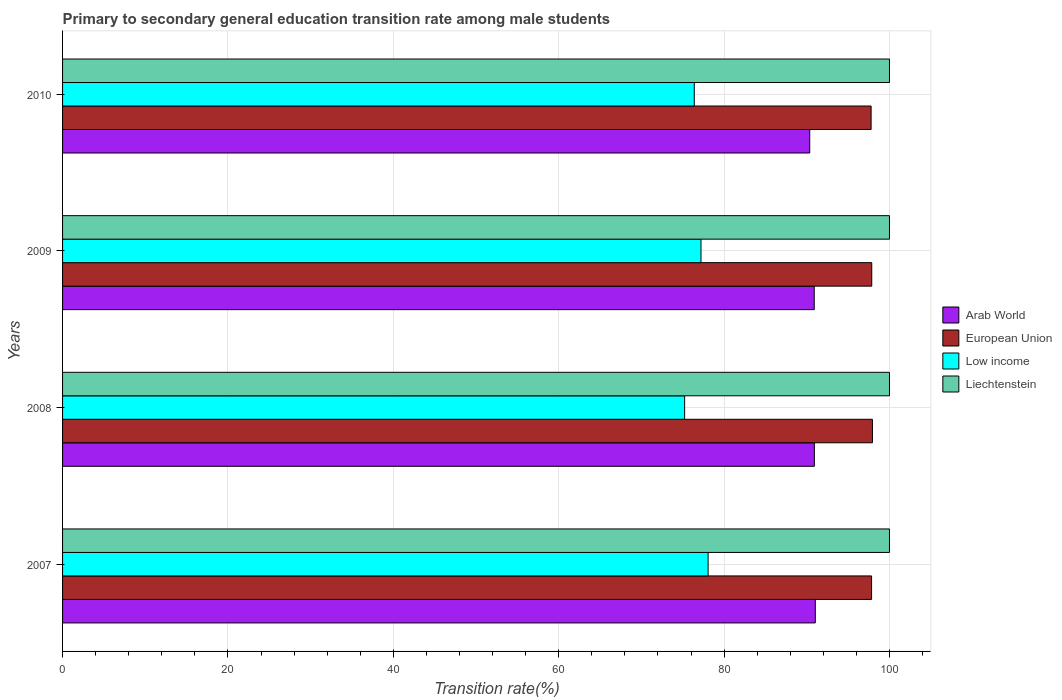How many different coloured bars are there?
Ensure brevity in your answer.  4. How many groups of bars are there?
Ensure brevity in your answer.  4. Are the number of bars on each tick of the Y-axis equal?
Offer a terse response. Yes. How many bars are there on the 2nd tick from the bottom?
Provide a succinct answer. 4. What is the label of the 4th group of bars from the top?
Your answer should be compact. 2007. In how many cases, is the number of bars for a given year not equal to the number of legend labels?
Provide a succinct answer. 0. What is the transition rate in Arab World in 2009?
Provide a succinct answer. 90.9. Across all years, what is the maximum transition rate in Arab World?
Provide a succinct answer. 91.03. Across all years, what is the minimum transition rate in Arab World?
Provide a succinct answer. 90.36. In which year was the transition rate in European Union minimum?
Your answer should be very brief. 2010. What is the total transition rate in Low income in the graph?
Your answer should be compact. 306.89. What is the difference between the transition rate in Arab World in 2007 and that in 2008?
Offer a very short reply. 0.12. What is the difference between the transition rate in Low income in 2008 and the transition rate in Liechtenstein in 2007?
Make the answer very short. -24.77. What is the average transition rate in Liechtenstein per year?
Your answer should be very brief. 100. In the year 2008, what is the difference between the transition rate in Liechtenstein and transition rate in Arab World?
Keep it short and to the point. 9.08. What is the ratio of the transition rate in European Union in 2007 to that in 2009?
Make the answer very short. 1. Is the transition rate in Low income in 2008 less than that in 2010?
Your response must be concise. Yes. What is the difference between the highest and the second highest transition rate in Low income?
Provide a short and direct response. 0.86. What is the difference between the highest and the lowest transition rate in Liechtenstein?
Give a very brief answer. 0. Is it the case that in every year, the sum of the transition rate in Arab World and transition rate in European Union is greater than the transition rate in Liechtenstein?
Keep it short and to the point. Yes. Does the graph contain any zero values?
Your response must be concise. No. Does the graph contain grids?
Provide a short and direct response. Yes. Where does the legend appear in the graph?
Your response must be concise. Center right. How are the legend labels stacked?
Provide a succinct answer. Vertical. What is the title of the graph?
Provide a short and direct response. Primary to secondary general education transition rate among male students. What is the label or title of the X-axis?
Make the answer very short. Transition rate(%). What is the Transition rate(%) in Arab World in 2007?
Your answer should be compact. 91.03. What is the Transition rate(%) of European Union in 2007?
Offer a very short reply. 97.84. What is the Transition rate(%) of Low income in 2007?
Offer a very short reply. 78.07. What is the Transition rate(%) in Arab World in 2008?
Make the answer very short. 90.92. What is the Transition rate(%) in European Union in 2008?
Provide a short and direct response. 97.94. What is the Transition rate(%) in Low income in 2008?
Provide a short and direct response. 75.23. What is the Transition rate(%) in Arab World in 2009?
Give a very brief answer. 90.9. What is the Transition rate(%) in European Union in 2009?
Provide a succinct answer. 97.86. What is the Transition rate(%) of Low income in 2009?
Keep it short and to the point. 77.21. What is the Transition rate(%) in Liechtenstein in 2009?
Give a very brief answer. 100. What is the Transition rate(%) in Arab World in 2010?
Provide a short and direct response. 90.36. What is the Transition rate(%) in European Union in 2010?
Provide a succinct answer. 97.78. What is the Transition rate(%) of Low income in 2010?
Your answer should be compact. 76.39. What is the Transition rate(%) in Liechtenstein in 2010?
Give a very brief answer. 100. Across all years, what is the maximum Transition rate(%) in Arab World?
Provide a succinct answer. 91.03. Across all years, what is the maximum Transition rate(%) in European Union?
Keep it short and to the point. 97.94. Across all years, what is the maximum Transition rate(%) in Low income?
Your answer should be very brief. 78.07. Across all years, what is the maximum Transition rate(%) in Liechtenstein?
Your response must be concise. 100. Across all years, what is the minimum Transition rate(%) in Arab World?
Provide a short and direct response. 90.36. Across all years, what is the minimum Transition rate(%) of European Union?
Your answer should be compact. 97.78. Across all years, what is the minimum Transition rate(%) in Low income?
Offer a terse response. 75.23. What is the total Transition rate(%) in Arab World in the graph?
Provide a succinct answer. 363.2. What is the total Transition rate(%) in European Union in the graph?
Your response must be concise. 391.41. What is the total Transition rate(%) of Low income in the graph?
Your answer should be very brief. 306.89. What is the total Transition rate(%) in Liechtenstein in the graph?
Your response must be concise. 400. What is the difference between the Transition rate(%) of Arab World in 2007 and that in 2008?
Make the answer very short. 0.12. What is the difference between the Transition rate(%) in European Union in 2007 and that in 2008?
Give a very brief answer. -0.1. What is the difference between the Transition rate(%) in Low income in 2007 and that in 2008?
Provide a short and direct response. 2.84. What is the difference between the Transition rate(%) in Liechtenstein in 2007 and that in 2008?
Ensure brevity in your answer.  0. What is the difference between the Transition rate(%) of Arab World in 2007 and that in 2009?
Offer a very short reply. 0.13. What is the difference between the Transition rate(%) in European Union in 2007 and that in 2009?
Your response must be concise. -0.02. What is the difference between the Transition rate(%) of Low income in 2007 and that in 2009?
Keep it short and to the point. 0.86. What is the difference between the Transition rate(%) in Arab World in 2007 and that in 2010?
Ensure brevity in your answer.  0.67. What is the difference between the Transition rate(%) in European Union in 2007 and that in 2010?
Your answer should be compact. 0.06. What is the difference between the Transition rate(%) of Low income in 2007 and that in 2010?
Offer a very short reply. 1.67. What is the difference between the Transition rate(%) in Liechtenstein in 2007 and that in 2010?
Offer a very short reply. 0. What is the difference between the Transition rate(%) of Arab World in 2008 and that in 2009?
Offer a terse response. 0.01. What is the difference between the Transition rate(%) of European Union in 2008 and that in 2009?
Offer a terse response. 0.08. What is the difference between the Transition rate(%) in Low income in 2008 and that in 2009?
Provide a short and direct response. -1.98. What is the difference between the Transition rate(%) in Liechtenstein in 2008 and that in 2009?
Your answer should be very brief. 0. What is the difference between the Transition rate(%) in Arab World in 2008 and that in 2010?
Make the answer very short. 0.56. What is the difference between the Transition rate(%) of European Union in 2008 and that in 2010?
Your answer should be very brief. 0.16. What is the difference between the Transition rate(%) in Low income in 2008 and that in 2010?
Provide a short and direct response. -1.17. What is the difference between the Transition rate(%) of Liechtenstein in 2008 and that in 2010?
Offer a very short reply. 0. What is the difference between the Transition rate(%) in Arab World in 2009 and that in 2010?
Provide a succinct answer. 0.54. What is the difference between the Transition rate(%) in European Union in 2009 and that in 2010?
Offer a very short reply. 0.08. What is the difference between the Transition rate(%) in Low income in 2009 and that in 2010?
Offer a very short reply. 0.81. What is the difference between the Transition rate(%) of Arab World in 2007 and the Transition rate(%) of European Union in 2008?
Ensure brevity in your answer.  -6.91. What is the difference between the Transition rate(%) of Arab World in 2007 and the Transition rate(%) of Low income in 2008?
Offer a terse response. 15.8. What is the difference between the Transition rate(%) in Arab World in 2007 and the Transition rate(%) in Liechtenstein in 2008?
Your answer should be compact. -8.97. What is the difference between the Transition rate(%) of European Union in 2007 and the Transition rate(%) of Low income in 2008?
Provide a succinct answer. 22.61. What is the difference between the Transition rate(%) of European Union in 2007 and the Transition rate(%) of Liechtenstein in 2008?
Provide a short and direct response. -2.16. What is the difference between the Transition rate(%) of Low income in 2007 and the Transition rate(%) of Liechtenstein in 2008?
Ensure brevity in your answer.  -21.93. What is the difference between the Transition rate(%) in Arab World in 2007 and the Transition rate(%) in European Union in 2009?
Your answer should be very brief. -6.83. What is the difference between the Transition rate(%) of Arab World in 2007 and the Transition rate(%) of Low income in 2009?
Make the answer very short. 13.83. What is the difference between the Transition rate(%) in Arab World in 2007 and the Transition rate(%) in Liechtenstein in 2009?
Provide a short and direct response. -8.97. What is the difference between the Transition rate(%) of European Union in 2007 and the Transition rate(%) of Low income in 2009?
Ensure brevity in your answer.  20.63. What is the difference between the Transition rate(%) in European Union in 2007 and the Transition rate(%) in Liechtenstein in 2009?
Give a very brief answer. -2.16. What is the difference between the Transition rate(%) in Low income in 2007 and the Transition rate(%) in Liechtenstein in 2009?
Your answer should be compact. -21.93. What is the difference between the Transition rate(%) of Arab World in 2007 and the Transition rate(%) of European Union in 2010?
Keep it short and to the point. -6.75. What is the difference between the Transition rate(%) of Arab World in 2007 and the Transition rate(%) of Low income in 2010?
Provide a short and direct response. 14.64. What is the difference between the Transition rate(%) of Arab World in 2007 and the Transition rate(%) of Liechtenstein in 2010?
Offer a terse response. -8.97. What is the difference between the Transition rate(%) in European Union in 2007 and the Transition rate(%) in Low income in 2010?
Offer a terse response. 21.44. What is the difference between the Transition rate(%) of European Union in 2007 and the Transition rate(%) of Liechtenstein in 2010?
Provide a succinct answer. -2.16. What is the difference between the Transition rate(%) in Low income in 2007 and the Transition rate(%) in Liechtenstein in 2010?
Provide a short and direct response. -21.93. What is the difference between the Transition rate(%) of Arab World in 2008 and the Transition rate(%) of European Union in 2009?
Ensure brevity in your answer.  -6.94. What is the difference between the Transition rate(%) in Arab World in 2008 and the Transition rate(%) in Low income in 2009?
Provide a short and direct response. 13.71. What is the difference between the Transition rate(%) in Arab World in 2008 and the Transition rate(%) in Liechtenstein in 2009?
Ensure brevity in your answer.  -9.08. What is the difference between the Transition rate(%) in European Union in 2008 and the Transition rate(%) in Low income in 2009?
Your answer should be compact. 20.73. What is the difference between the Transition rate(%) in European Union in 2008 and the Transition rate(%) in Liechtenstein in 2009?
Offer a terse response. -2.06. What is the difference between the Transition rate(%) of Low income in 2008 and the Transition rate(%) of Liechtenstein in 2009?
Provide a short and direct response. -24.77. What is the difference between the Transition rate(%) of Arab World in 2008 and the Transition rate(%) of European Union in 2010?
Give a very brief answer. -6.86. What is the difference between the Transition rate(%) of Arab World in 2008 and the Transition rate(%) of Low income in 2010?
Ensure brevity in your answer.  14.52. What is the difference between the Transition rate(%) of Arab World in 2008 and the Transition rate(%) of Liechtenstein in 2010?
Your response must be concise. -9.08. What is the difference between the Transition rate(%) of European Union in 2008 and the Transition rate(%) of Low income in 2010?
Provide a succinct answer. 21.54. What is the difference between the Transition rate(%) in European Union in 2008 and the Transition rate(%) in Liechtenstein in 2010?
Your answer should be very brief. -2.06. What is the difference between the Transition rate(%) in Low income in 2008 and the Transition rate(%) in Liechtenstein in 2010?
Provide a succinct answer. -24.77. What is the difference between the Transition rate(%) of Arab World in 2009 and the Transition rate(%) of European Union in 2010?
Offer a terse response. -6.88. What is the difference between the Transition rate(%) in Arab World in 2009 and the Transition rate(%) in Low income in 2010?
Ensure brevity in your answer.  14.51. What is the difference between the Transition rate(%) of Arab World in 2009 and the Transition rate(%) of Liechtenstein in 2010?
Make the answer very short. -9.1. What is the difference between the Transition rate(%) of European Union in 2009 and the Transition rate(%) of Low income in 2010?
Make the answer very short. 21.46. What is the difference between the Transition rate(%) in European Union in 2009 and the Transition rate(%) in Liechtenstein in 2010?
Give a very brief answer. -2.14. What is the difference between the Transition rate(%) of Low income in 2009 and the Transition rate(%) of Liechtenstein in 2010?
Make the answer very short. -22.79. What is the average Transition rate(%) in Arab World per year?
Keep it short and to the point. 90.8. What is the average Transition rate(%) of European Union per year?
Ensure brevity in your answer.  97.85. What is the average Transition rate(%) of Low income per year?
Your answer should be compact. 76.72. What is the average Transition rate(%) in Liechtenstein per year?
Give a very brief answer. 100. In the year 2007, what is the difference between the Transition rate(%) of Arab World and Transition rate(%) of European Union?
Keep it short and to the point. -6.8. In the year 2007, what is the difference between the Transition rate(%) in Arab World and Transition rate(%) in Low income?
Keep it short and to the point. 12.96. In the year 2007, what is the difference between the Transition rate(%) of Arab World and Transition rate(%) of Liechtenstein?
Provide a short and direct response. -8.97. In the year 2007, what is the difference between the Transition rate(%) in European Union and Transition rate(%) in Low income?
Make the answer very short. 19.77. In the year 2007, what is the difference between the Transition rate(%) of European Union and Transition rate(%) of Liechtenstein?
Provide a succinct answer. -2.16. In the year 2007, what is the difference between the Transition rate(%) in Low income and Transition rate(%) in Liechtenstein?
Provide a short and direct response. -21.93. In the year 2008, what is the difference between the Transition rate(%) in Arab World and Transition rate(%) in European Union?
Provide a short and direct response. -7.02. In the year 2008, what is the difference between the Transition rate(%) of Arab World and Transition rate(%) of Low income?
Make the answer very short. 15.69. In the year 2008, what is the difference between the Transition rate(%) of Arab World and Transition rate(%) of Liechtenstein?
Provide a succinct answer. -9.08. In the year 2008, what is the difference between the Transition rate(%) in European Union and Transition rate(%) in Low income?
Offer a very short reply. 22.71. In the year 2008, what is the difference between the Transition rate(%) in European Union and Transition rate(%) in Liechtenstein?
Ensure brevity in your answer.  -2.06. In the year 2008, what is the difference between the Transition rate(%) of Low income and Transition rate(%) of Liechtenstein?
Your answer should be compact. -24.77. In the year 2009, what is the difference between the Transition rate(%) of Arab World and Transition rate(%) of European Union?
Make the answer very short. -6.96. In the year 2009, what is the difference between the Transition rate(%) of Arab World and Transition rate(%) of Low income?
Your answer should be very brief. 13.7. In the year 2009, what is the difference between the Transition rate(%) of Arab World and Transition rate(%) of Liechtenstein?
Offer a very short reply. -9.1. In the year 2009, what is the difference between the Transition rate(%) of European Union and Transition rate(%) of Low income?
Offer a very short reply. 20.65. In the year 2009, what is the difference between the Transition rate(%) in European Union and Transition rate(%) in Liechtenstein?
Provide a succinct answer. -2.14. In the year 2009, what is the difference between the Transition rate(%) in Low income and Transition rate(%) in Liechtenstein?
Give a very brief answer. -22.79. In the year 2010, what is the difference between the Transition rate(%) in Arab World and Transition rate(%) in European Union?
Your answer should be very brief. -7.42. In the year 2010, what is the difference between the Transition rate(%) of Arab World and Transition rate(%) of Low income?
Provide a short and direct response. 13.96. In the year 2010, what is the difference between the Transition rate(%) in Arab World and Transition rate(%) in Liechtenstein?
Provide a succinct answer. -9.64. In the year 2010, what is the difference between the Transition rate(%) in European Union and Transition rate(%) in Low income?
Ensure brevity in your answer.  21.38. In the year 2010, what is the difference between the Transition rate(%) in European Union and Transition rate(%) in Liechtenstein?
Ensure brevity in your answer.  -2.22. In the year 2010, what is the difference between the Transition rate(%) in Low income and Transition rate(%) in Liechtenstein?
Provide a succinct answer. -23.61. What is the ratio of the Transition rate(%) of European Union in 2007 to that in 2008?
Provide a succinct answer. 1. What is the ratio of the Transition rate(%) in Low income in 2007 to that in 2008?
Provide a short and direct response. 1.04. What is the ratio of the Transition rate(%) of Liechtenstein in 2007 to that in 2008?
Your answer should be very brief. 1. What is the ratio of the Transition rate(%) of European Union in 2007 to that in 2009?
Offer a very short reply. 1. What is the ratio of the Transition rate(%) in Low income in 2007 to that in 2009?
Your answer should be very brief. 1.01. What is the ratio of the Transition rate(%) in Liechtenstein in 2007 to that in 2009?
Provide a succinct answer. 1. What is the ratio of the Transition rate(%) in Arab World in 2007 to that in 2010?
Your answer should be very brief. 1.01. What is the ratio of the Transition rate(%) of Low income in 2007 to that in 2010?
Make the answer very short. 1.02. What is the ratio of the Transition rate(%) of Low income in 2008 to that in 2009?
Give a very brief answer. 0.97. What is the ratio of the Transition rate(%) in Liechtenstein in 2008 to that in 2009?
Offer a very short reply. 1. What is the ratio of the Transition rate(%) of Arab World in 2008 to that in 2010?
Your answer should be compact. 1.01. What is the ratio of the Transition rate(%) of Low income in 2008 to that in 2010?
Your answer should be compact. 0.98. What is the ratio of the Transition rate(%) in Liechtenstein in 2008 to that in 2010?
Your answer should be compact. 1. What is the ratio of the Transition rate(%) of Low income in 2009 to that in 2010?
Your answer should be compact. 1.01. What is the difference between the highest and the second highest Transition rate(%) in Arab World?
Your response must be concise. 0.12. What is the difference between the highest and the second highest Transition rate(%) of European Union?
Your answer should be very brief. 0.08. What is the difference between the highest and the second highest Transition rate(%) of Low income?
Your response must be concise. 0.86. What is the difference between the highest and the second highest Transition rate(%) of Liechtenstein?
Ensure brevity in your answer.  0. What is the difference between the highest and the lowest Transition rate(%) of Arab World?
Offer a terse response. 0.67. What is the difference between the highest and the lowest Transition rate(%) in European Union?
Keep it short and to the point. 0.16. What is the difference between the highest and the lowest Transition rate(%) of Low income?
Offer a terse response. 2.84. What is the difference between the highest and the lowest Transition rate(%) in Liechtenstein?
Make the answer very short. 0. 